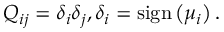<formula> <loc_0><loc_0><loc_500><loc_500>Q _ { i j } = { \delta } _ { i } { \delta } _ { j } , { \delta } _ { i } = s i g n \left ( { \mu } _ { i } \right ) .</formula> 